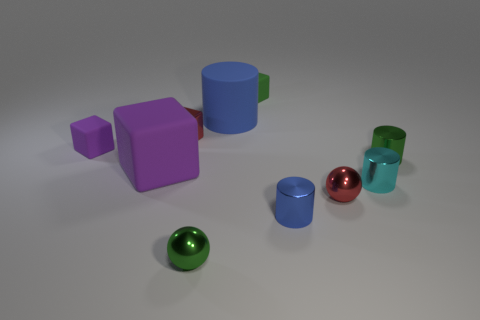Subtract all cyan blocks. Subtract all cyan cylinders. How many blocks are left? 4 Subtract all cubes. How many objects are left? 6 Add 1 cylinders. How many cylinders are left? 5 Add 4 green rubber cubes. How many green rubber cubes exist? 5 Subtract 0 cyan cubes. How many objects are left? 10 Subtract all gray blocks. Subtract all small red metal balls. How many objects are left? 9 